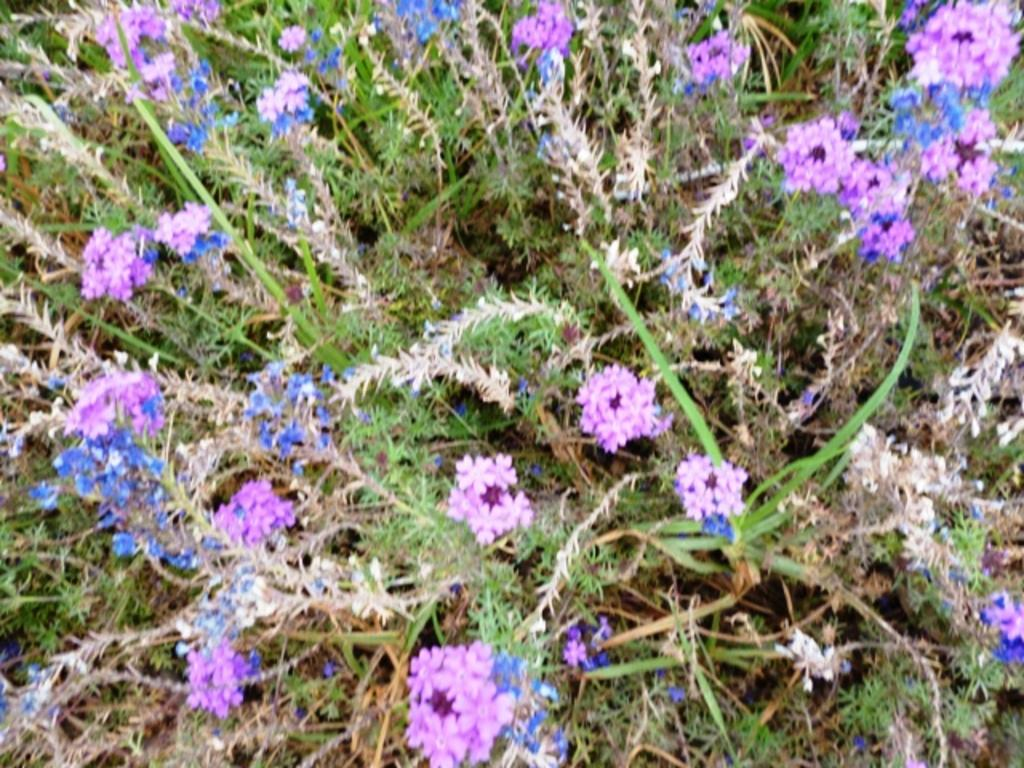What type of plant life is visible in the image? There are flowers and leaves in the image. Can you describe the flowers in the image? Unfortunately, the facts provided do not give specific details about the flowers. What is the context or setting of the image? The facts provided do not give information about the context or setting of the image. What type of appliance is visible in the image? There is no appliance present in the image. What flavor of cracker is shown in the image? There is no cracker present in the image. 